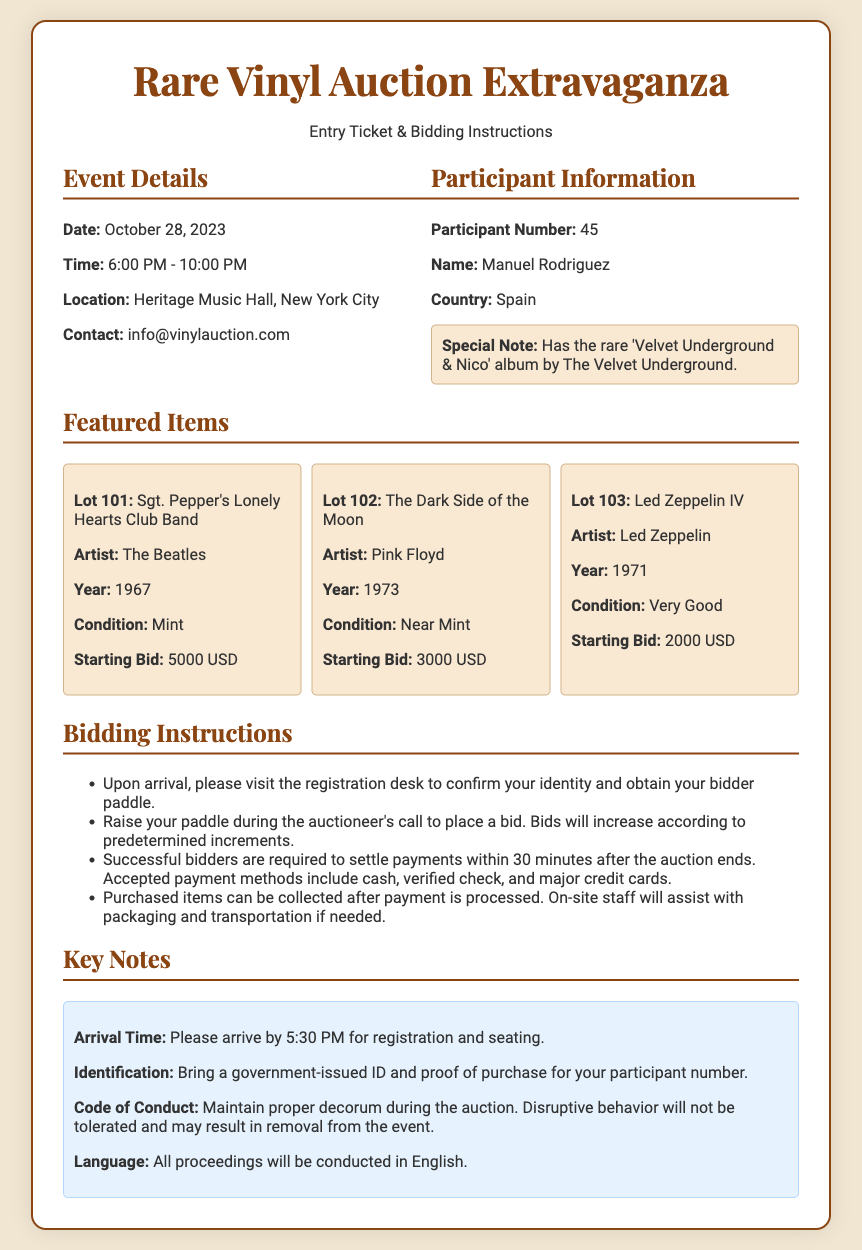What is the date of the event? The date of the event is specified in the document under Event Details.
Answer: October 28, 2023 What is the participant number? The participant number is mentioned in the Participant Information section of the document.
Answer: 45 Who is the contact for the event? The contact information is listed in the Event Details section.
Answer: info@vinylauction.com What is the starting bid for 'Sgt. Pepper's Lonely Hearts Club Band'? The starting bid for this item can be found in the Featured Items section.
Answer: 5000 USD What is the condition of 'The Dark Side of the Moon'? The condition for this vinyl is detailed in the Featured Items section.
Answer: Near Mint What time should participants arrive for registration? The arrival time is stated in the Key Notes section.
Answer: 5:30 PM How long do successful bidders have to settle payments? This information is given in the Bidding Instructions section of the document.
Answer: 30 minutes What is required for identification at the event? The identification requirements are listed in the Key Notes section.
Answer: Government-issued ID What happens to disruptive behavior during the auction? The consequences for disruptive behavior are described in the Key Notes section.
Answer: Removal from the event 